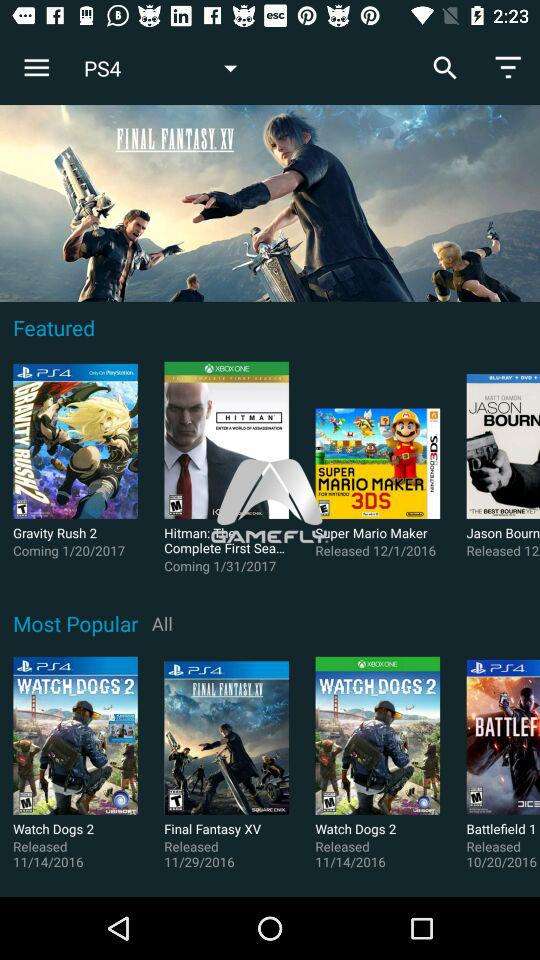What are the most popular games for the PS4? The most popular games for the PS4 are "Watch Dogs 2", "Final Fantasy XV" and "Battlefield 1". 